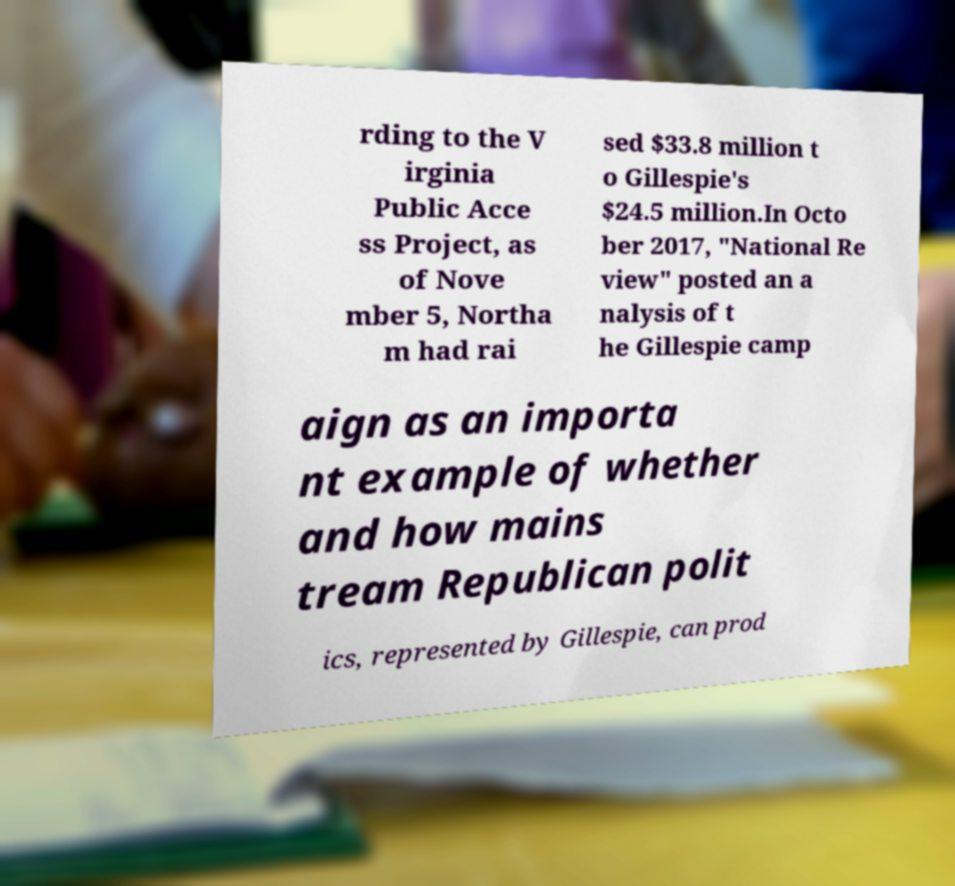Could you assist in decoding the text presented in this image and type it out clearly? rding to the V irginia Public Acce ss Project, as of Nove mber 5, Northa m had rai sed $33.8 million t o Gillespie's $24.5 million.In Octo ber 2017, "National Re view" posted an a nalysis of t he Gillespie camp aign as an importa nt example of whether and how mains tream Republican polit ics, represented by Gillespie, can prod 